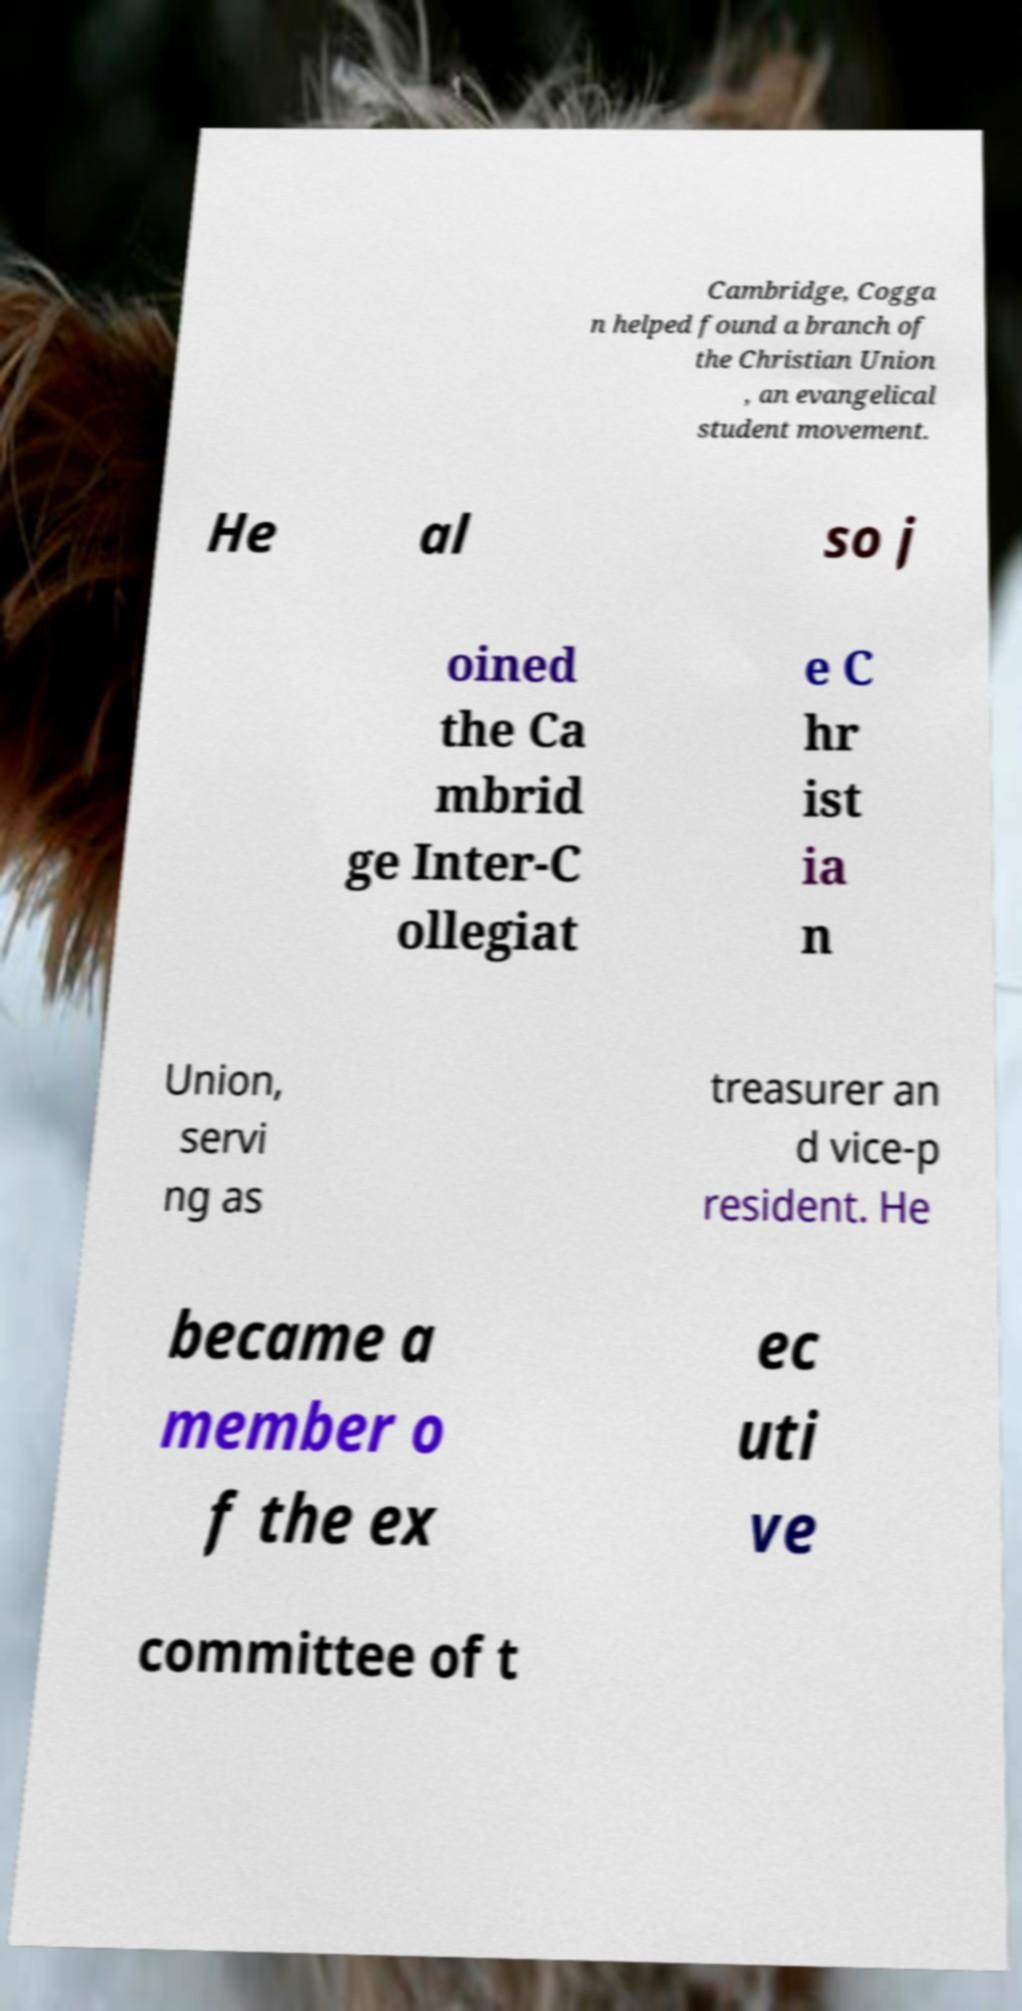Can you accurately transcribe the text from the provided image for me? Cambridge, Cogga n helped found a branch of the Christian Union , an evangelical student movement. He al so j oined the Ca mbrid ge Inter-C ollegiat e C hr ist ia n Union, servi ng as treasurer an d vice-p resident. He became a member o f the ex ec uti ve committee of t 